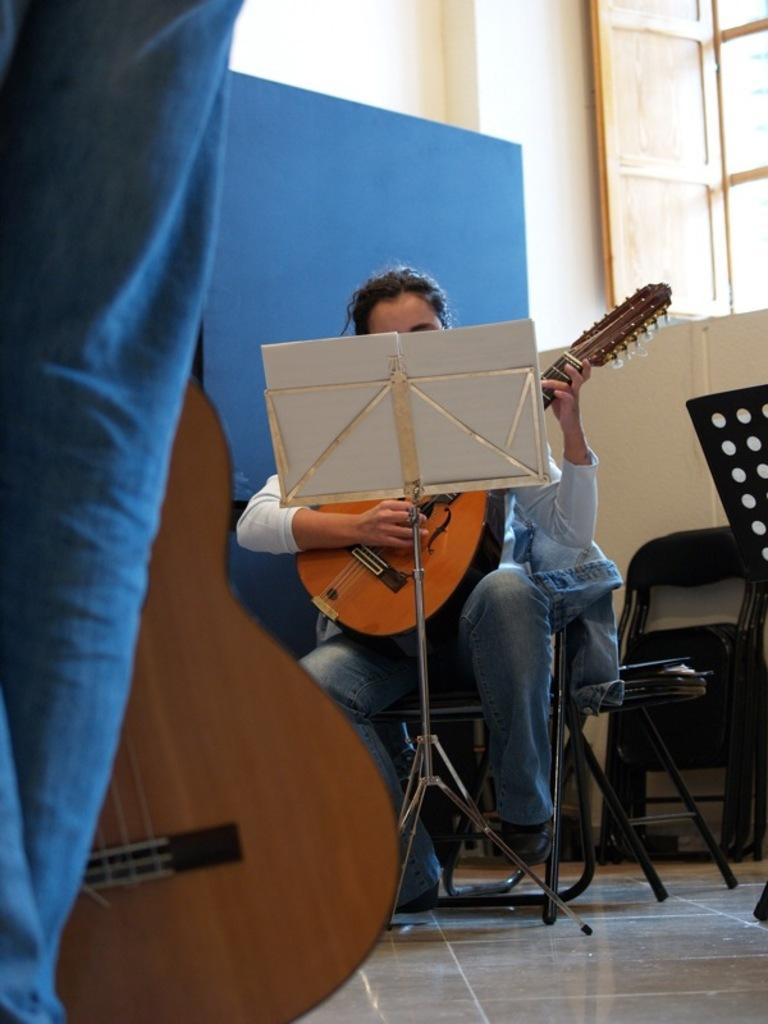How would you summarize this image in a sentence or two? This person is sitting on a chair and playing a guitar. In-front of this person there is a book stand. This man is standing and holding a guitar. This is window with doors. 